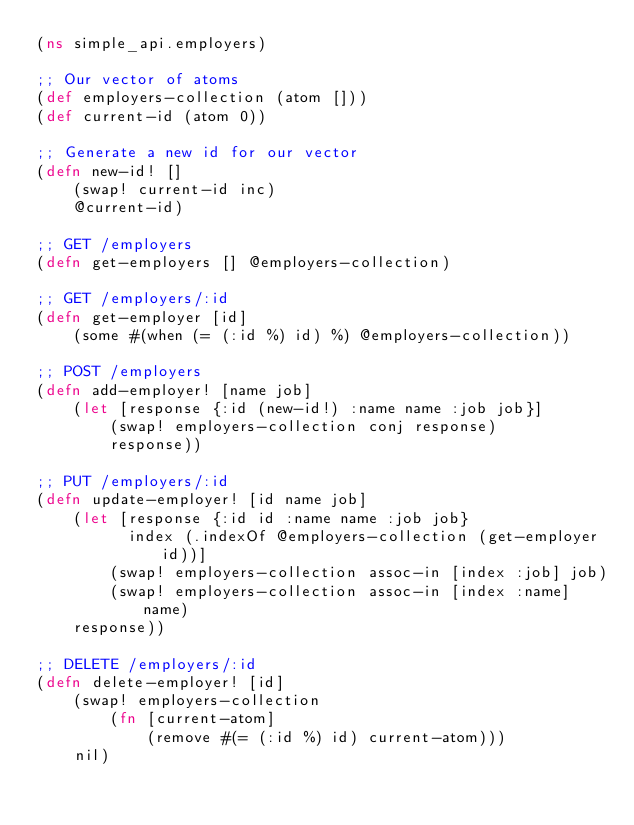Convert code to text. <code><loc_0><loc_0><loc_500><loc_500><_Clojure_>(ns simple_api.employers)

;; Our vector of atoms
(def employers-collection (atom []))
(def current-id (atom 0))

;; Generate a new id for our vector
(defn new-id! []
    (swap! current-id inc)
    @current-id)

;; GET /employers
(defn get-employers [] @employers-collection)

;; GET /employers/:id
(defn get-employer [id] 
    (some #(when (= (:id %) id) %) @employers-collection))

;; POST /employers
(defn add-employer! [name job]
    (let [response {:id (new-id!) :name name :job job}]
        (swap! employers-collection conj response)
        response))

;; PUT /employers/:id
(defn update-employer! [id name job]
    (let [response {:id id :name name :job job} 
          index (.indexOf @employers-collection (get-employer id))]
        (swap! employers-collection assoc-in [index :job] job)
        (swap! employers-collection assoc-in [index :name] name)
    response))

;; DELETE /employers/:id
(defn delete-employer! [id]
    (swap! employers-collection 
        (fn [current-atom] 
            (remove #(= (:id %) id) current-atom)))
    nil)</code> 